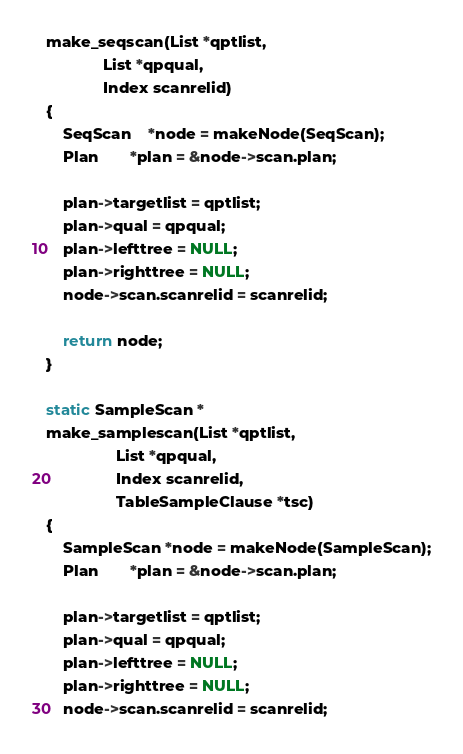<code> <loc_0><loc_0><loc_500><loc_500><_C_>make_seqscan(List *qptlist,
			 List *qpqual,
			 Index scanrelid)
{
	SeqScan    *node = makeNode(SeqScan);
	Plan	   *plan = &node->scan.plan;

	plan->targetlist = qptlist;
	plan->qual = qpqual;
	plan->lefttree = NULL;
	plan->righttree = NULL;
	node->scan.scanrelid = scanrelid;

	return node;
}

static SampleScan *
make_samplescan(List *qptlist,
				List *qpqual,
				Index scanrelid,
				TableSampleClause *tsc)
{
	SampleScan *node = makeNode(SampleScan);
	Plan	   *plan = &node->scan.plan;

	plan->targetlist = qptlist;
	plan->qual = qpqual;
	plan->lefttree = NULL;
	plan->righttree = NULL;
	node->scan.scanrelid = scanrelid;</code> 